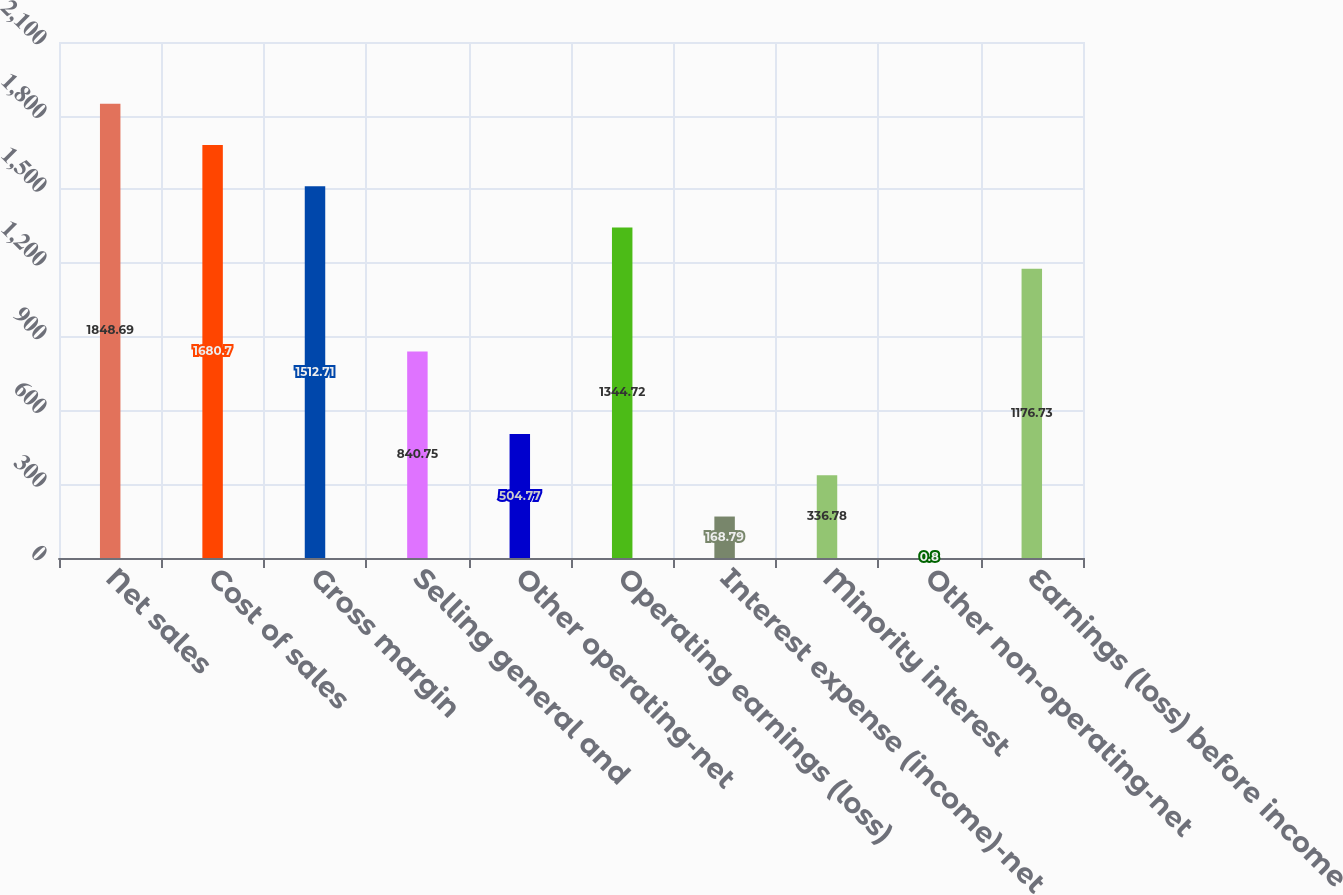Convert chart to OTSL. <chart><loc_0><loc_0><loc_500><loc_500><bar_chart><fcel>Net sales<fcel>Cost of sales<fcel>Gross margin<fcel>Selling general and<fcel>Other operating-net<fcel>Operating earnings (loss)<fcel>Interest expense (income)-net<fcel>Minority interest<fcel>Other non-operating-net<fcel>Earnings (loss) before income<nl><fcel>1848.69<fcel>1680.7<fcel>1512.71<fcel>840.75<fcel>504.77<fcel>1344.72<fcel>168.79<fcel>336.78<fcel>0.8<fcel>1176.73<nl></chart> 